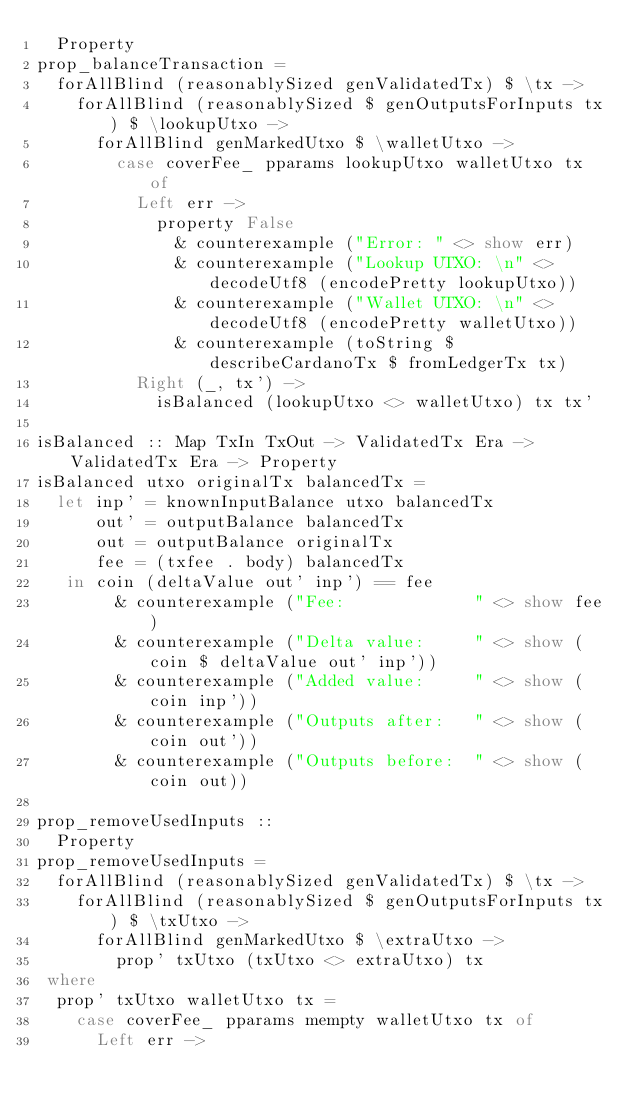Convert code to text. <code><loc_0><loc_0><loc_500><loc_500><_Haskell_>  Property
prop_balanceTransaction =
  forAllBlind (reasonablySized genValidatedTx) $ \tx ->
    forAllBlind (reasonablySized $ genOutputsForInputs tx) $ \lookupUtxo ->
      forAllBlind genMarkedUtxo $ \walletUtxo ->
        case coverFee_ pparams lookupUtxo walletUtxo tx of
          Left err ->
            property False
              & counterexample ("Error: " <> show err)
              & counterexample ("Lookup UTXO: \n" <> decodeUtf8 (encodePretty lookupUtxo))
              & counterexample ("Wallet UTXO: \n" <> decodeUtf8 (encodePretty walletUtxo))
              & counterexample (toString $ describeCardanoTx $ fromLedgerTx tx)
          Right (_, tx') ->
            isBalanced (lookupUtxo <> walletUtxo) tx tx'

isBalanced :: Map TxIn TxOut -> ValidatedTx Era -> ValidatedTx Era -> Property
isBalanced utxo originalTx balancedTx =
  let inp' = knownInputBalance utxo balancedTx
      out' = outputBalance balancedTx
      out = outputBalance originalTx
      fee = (txfee . body) balancedTx
   in coin (deltaValue out' inp') == fee
        & counterexample ("Fee:             " <> show fee)
        & counterexample ("Delta value:     " <> show (coin $ deltaValue out' inp'))
        & counterexample ("Added value:     " <> show (coin inp'))
        & counterexample ("Outputs after:   " <> show (coin out'))
        & counterexample ("Outputs before:  " <> show (coin out))

prop_removeUsedInputs ::
  Property
prop_removeUsedInputs =
  forAllBlind (reasonablySized genValidatedTx) $ \tx ->
    forAllBlind (reasonablySized $ genOutputsForInputs tx) $ \txUtxo ->
      forAllBlind genMarkedUtxo $ \extraUtxo ->
        prop' txUtxo (txUtxo <> extraUtxo) tx
 where
  prop' txUtxo walletUtxo tx =
    case coverFee_ pparams mempty walletUtxo tx of
      Left err -></code> 